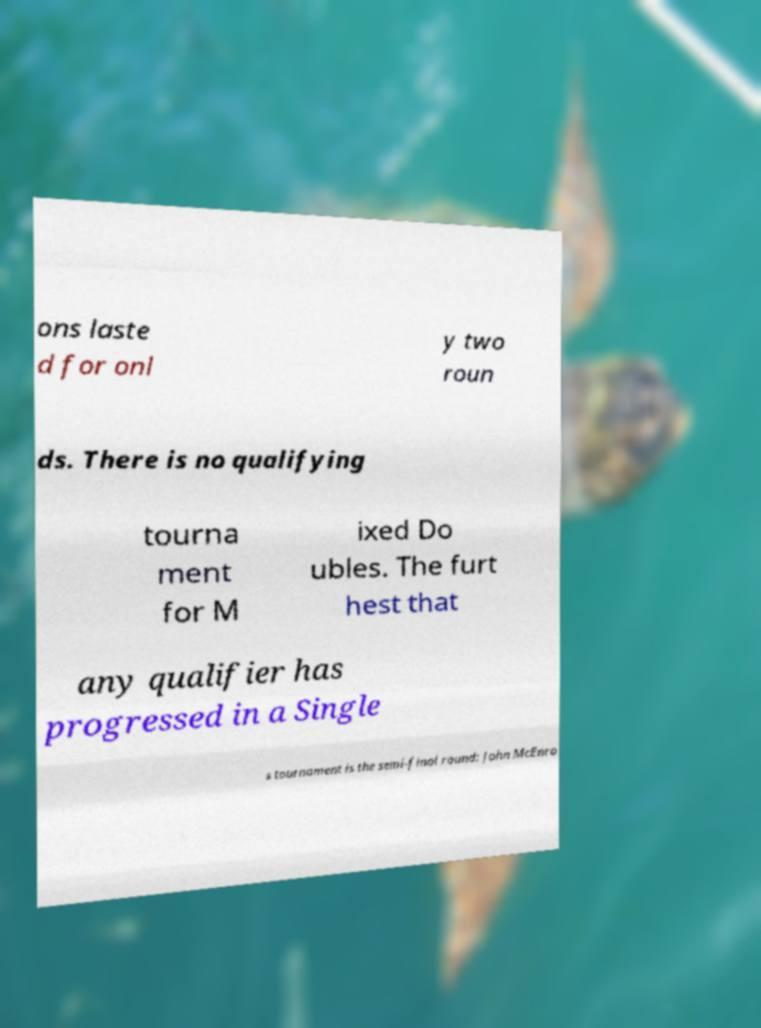I need the written content from this picture converted into text. Can you do that? ons laste d for onl y two roun ds. There is no qualifying tourna ment for M ixed Do ubles. The furt hest that any qualifier has progressed in a Single s tournament is the semi-final round: John McEnro 